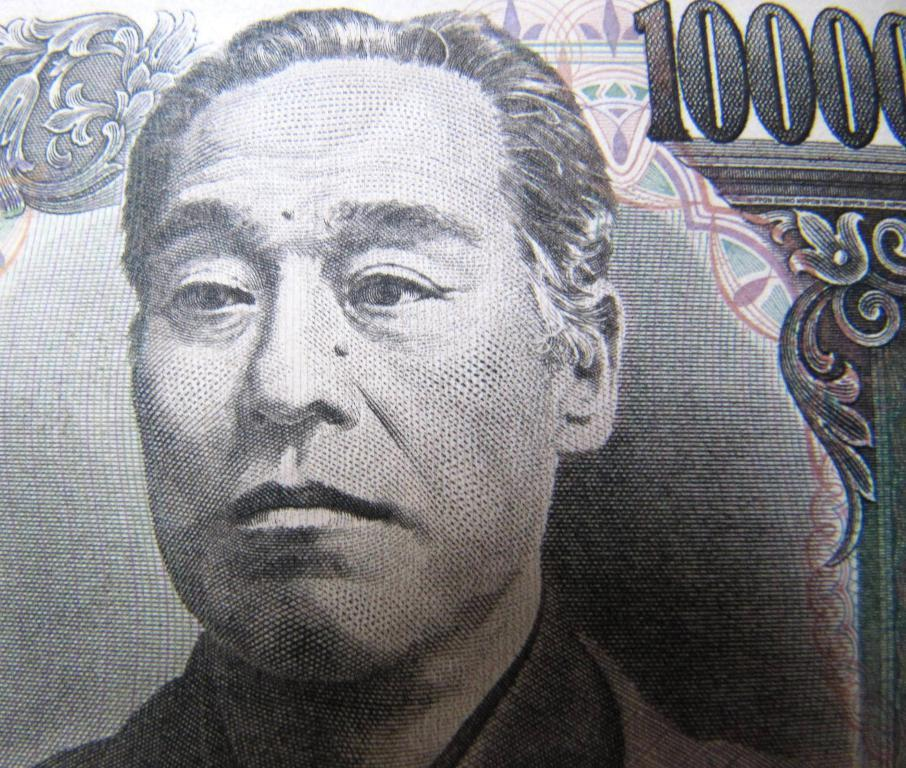What is depicted on the paper in the image? There is a sketch of a person in the image. What else can be seen on the paper besides the sketch? There is text on the paper in the image. How many beans are present on the paper in the image? There are no beans visible on the paper in the image. What type of children are depicted in the image? There are no children depicted in the image; it features a sketch of a person and text. 